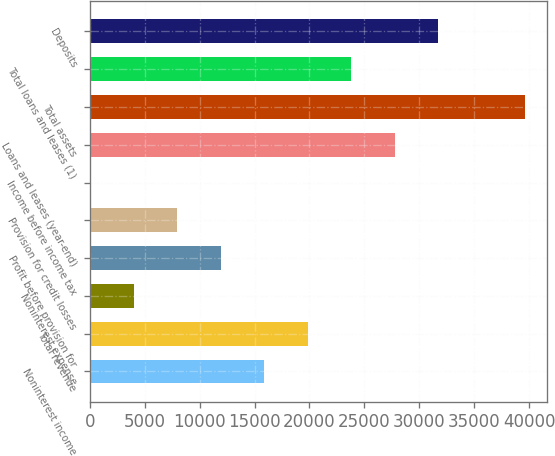Convert chart to OTSL. <chart><loc_0><loc_0><loc_500><loc_500><bar_chart><fcel>Noninterest income<fcel>Total revenue<fcel>Noninterest expense<fcel>Profit before provision for<fcel>Provision for credit losses<fcel>Income before income tax<fcel>Loans and leases (year-end)<fcel>Total assets<fcel>Total loans and leases (1)<fcel>Deposits<nl><fcel>15873.6<fcel>19834<fcel>3992.4<fcel>11913.2<fcel>7952.8<fcel>32<fcel>27754.8<fcel>39636<fcel>23794.4<fcel>31715.2<nl></chart> 